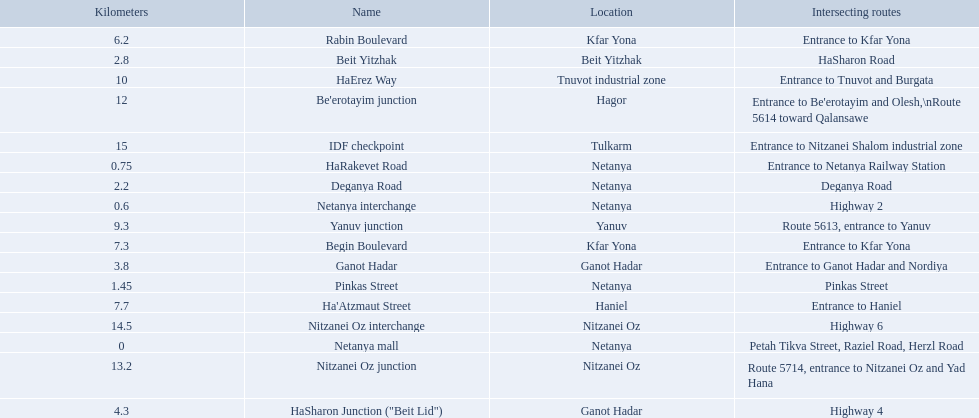What is the intersecting route of rabin boulevard? Entrance to Kfar Yona. Which portion has this intersecting route? Begin Boulevard. What are all the names? Netanya mall, Netanya interchange, HaRakevet Road, Pinkas Street, Deganya Road, Beit Yitzhak, Ganot Hadar, HaSharon Junction ("Beit Lid"), Rabin Boulevard, Begin Boulevard, Ha'Atzmaut Street, Yanuv junction, HaErez Way, Be'erotayim junction, Nitzanei Oz junction, Nitzanei Oz interchange, IDF checkpoint. Where do they intersect? Petah Tikva Street, Raziel Road, Herzl Road, Highway 2, Entrance to Netanya Railway Station, Pinkas Street, Deganya Road, HaSharon Road, Entrance to Ganot Hadar and Nordiya, Highway 4, Entrance to Kfar Yona, Entrance to Kfar Yona, Entrance to Haniel, Route 5613, entrance to Yanuv, Entrance to Tnuvot and Burgata, Entrance to Be'erotayim and Olesh,\nRoute 5614 toward Qalansawe, Route 5714, entrance to Nitzanei Oz and Yad Hana, Highway 6, Entrance to Nitzanei Shalom industrial zone. And which shares an intersection with rabin boulevard? Begin Boulevard. 